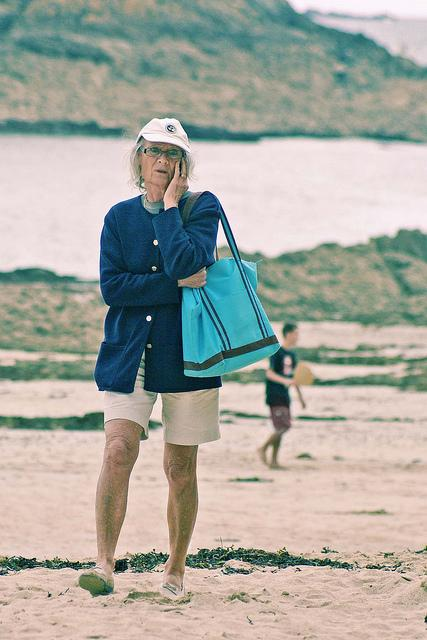What is the old woman doing? walking 